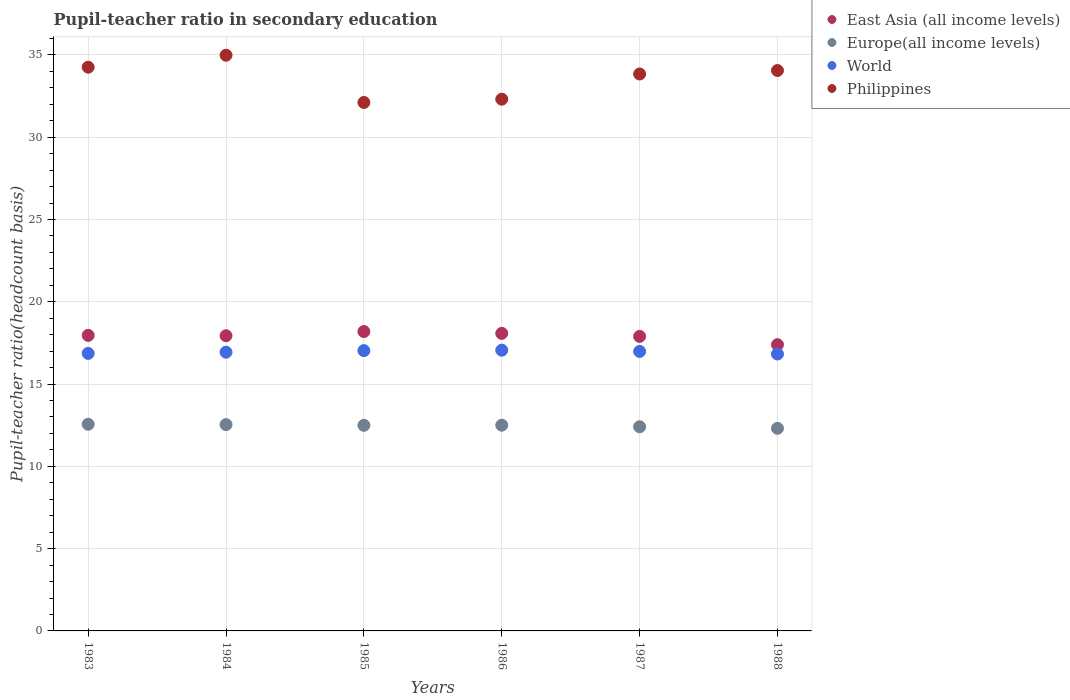What is the pupil-teacher ratio in secondary education in East Asia (all income levels) in 1983?
Your response must be concise. 17.96. Across all years, what is the maximum pupil-teacher ratio in secondary education in Philippines?
Offer a very short reply. 34.98. Across all years, what is the minimum pupil-teacher ratio in secondary education in World?
Provide a succinct answer. 16.83. In which year was the pupil-teacher ratio in secondary education in Philippines maximum?
Provide a short and direct response. 1984. What is the total pupil-teacher ratio in secondary education in Philippines in the graph?
Ensure brevity in your answer.  201.56. What is the difference between the pupil-teacher ratio in secondary education in World in 1985 and that in 1987?
Your response must be concise. 0.05. What is the difference between the pupil-teacher ratio in secondary education in Europe(all income levels) in 1986 and the pupil-teacher ratio in secondary education in East Asia (all income levels) in 1987?
Keep it short and to the point. -5.4. What is the average pupil-teacher ratio in secondary education in World per year?
Provide a short and direct response. 16.95. In the year 1983, what is the difference between the pupil-teacher ratio in secondary education in Philippines and pupil-teacher ratio in secondary education in World?
Provide a short and direct response. 17.39. In how many years, is the pupil-teacher ratio in secondary education in World greater than 11?
Your answer should be compact. 6. What is the ratio of the pupil-teacher ratio in secondary education in Europe(all income levels) in 1983 to that in 1985?
Keep it short and to the point. 1.01. What is the difference between the highest and the second highest pupil-teacher ratio in secondary education in East Asia (all income levels)?
Offer a terse response. 0.11. What is the difference between the highest and the lowest pupil-teacher ratio in secondary education in World?
Make the answer very short. 0.23. In how many years, is the pupil-teacher ratio in secondary education in World greater than the average pupil-teacher ratio in secondary education in World taken over all years?
Provide a short and direct response. 3. Is the sum of the pupil-teacher ratio in secondary education in Europe(all income levels) in 1984 and 1985 greater than the maximum pupil-teacher ratio in secondary education in Philippines across all years?
Provide a succinct answer. No. Is it the case that in every year, the sum of the pupil-teacher ratio in secondary education in East Asia (all income levels) and pupil-teacher ratio in secondary education in Europe(all income levels)  is greater than the sum of pupil-teacher ratio in secondary education in World and pupil-teacher ratio in secondary education in Philippines?
Offer a very short reply. No. Is it the case that in every year, the sum of the pupil-teacher ratio in secondary education in World and pupil-teacher ratio in secondary education in Europe(all income levels)  is greater than the pupil-teacher ratio in secondary education in Philippines?
Offer a terse response. No. Is the pupil-teacher ratio in secondary education in Philippines strictly less than the pupil-teacher ratio in secondary education in World over the years?
Provide a succinct answer. No. Does the graph contain any zero values?
Make the answer very short. No. Does the graph contain grids?
Provide a short and direct response. Yes. What is the title of the graph?
Offer a very short reply. Pupil-teacher ratio in secondary education. What is the label or title of the X-axis?
Provide a short and direct response. Years. What is the label or title of the Y-axis?
Keep it short and to the point. Pupil-teacher ratio(headcount basis). What is the Pupil-teacher ratio(headcount basis) of East Asia (all income levels) in 1983?
Offer a terse response. 17.96. What is the Pupil-teacher ratio(headcount basis) in Europe(all income levels) in 1983?
Make the answer very short. 12.56. What is the Pupil-teacher ratio(headcount basis) of World in 1983?
Provide a short and direct response. 16.86. What is the Pupil-teacher ratio(headcount basis) in Philippines in 1983?
Make the answer very short. 34.26. What is the Pupil-teacher ratio(headcount basis) in East Asia (all income levels) in 1984?
Keep it short and to the point. 17.94. What is the Pupil-teacher ratio(headcount basis) in Europe(all income levels) in 1984?
Give a very brief answer. 12.54. What is the Pupil-teacher ratio(headcount basis) in World in 1984?
Your answer should be compact. 16.94. What is the Pupil-teacher ratio(headcount basis) in Philippines in 1984?
Make the answer very short. 34.98. What is the Pupil-teacher ratio(headcount basis) of East Asia (all income levels) in 1985?
Keep it short and to the point. 18.19. What is the Pupil-teacher ratio(headcount basis) of Europe(all income levels) in 1985?
Ensure brevity in your answer.  12.49. What is the Pupil-teacher ratio(headcount basis) of World in 1985?
Make the answer very short. 17.03. What is the Pupil-teacher ratio(headcount basis) in Philippines in 1985?
Your answer should be compact. 32.11. What is the Pupil-teacher ratio(headcount basis) of East Asia (all income levels) in 1986?
Provide a succinct answer. 18.08. What is the Pupil-teacher ratio(headcount basis) in Europe(all income levels) in 1986?
Provide a short and direct response. 12.5. What is the Pupil-teacher ratio(headcount basis) of World in 1986?
Provide a succinct answer. 17.06. What is the Pupil-teacher ratio(headcount basis) in Philippines in 1986?
Your answer should be compact. 32.31. What is the Pupil-teacher ratio(headcount basis) of East Asia (all income levels) in 1987?
Your response must be concise. 17.9. What is the Pupil-teacher ratio(headcount basis) in Europe(all income levels) in 1987?
Your response must be concise. 12.41. What is the Pupil-teacher ratio(headcount basis) in World in 1987?
Make the answer very short. 16.98. What is the Pupil-teacher ratio(headcount basis) of Philippines in 1987?
Your answer should be very brief. 33.84. What is the Pupil-teacher ratio(headcount basis) in East Asia (all income levels) in 1988?
Provide a succinct answer. 17.4. What is the Pupil-teacher ratio(headcount basis) of Europe(all income levels) in 1988?
Offer a terse response. 12.31. What is the Pupil-teacher ratio(headcount basis) in World in 1988?
Offer a very short reply. 16.83. What is the Pupil-teacher ratio(headcount basis) of Philippines in 1988?
Your answer should be compact. 34.06. Across all years, what is the maximum Pupil-teacher ratio(headcount basis) of East Asia (all income levels)?
Offer a terse response. 18.19. Across all years, what is the maximum Pupil-teacher ratio(headcount basis) of Europe(all income levels)?
Provide a short and direct response. 12.56. Across all years, what is the maximum Pupil-teacher ratio(headcount basis) of World?
Keep it short and to the point. 17.06. Across all years, what is the maximum Pupil-teacher ratio(headcount basis) of Philippines?
Your response must be concise. 34.98. Across all years, what is the minimum Pupil-teacher ratio(headcount basis) in East Asia (all income levels)?
Your answer should be compact. 17.4. Across all years, what is the minimum Pupil-teacher ratio(headcount basis) in Europe(all income levels)?
Provide a short and direct response. 12.31. Across all years, what is the minimum Pupil-teacher ratio(headcount basis) of World?
Provide a succinct answer. 16.83. Across all years, what is the minimum Pupil-teacher ratio(headcount basis) of Philippines?
Give a very brief answer. 32.11. What is the total Pupil-teacher ratio(headcount basis) of East Asia (all income levels) in the graph?
Give a very brief answer. 107.47. What is the total Pupil-teacher ratio(headcount basis) in Europe(all income levels) in the graph?
Provide a succinct answer. 74.81. What is the total Pupil-teacher ratio(headcount basis) of World in the graph?
Ensure brevity in your answer.  101.7. What is the total Pupil-teacher ratio(headcount basis) of Philippines in the graph?
Give a very brief answer. 201.56. What is the difference between the Pupil-teacher ratio(headcount basis) of East Asia (all income levels) in 1983 and that in 1984?
Provide a succinct answer. 0.02. What is the difference between the Pupil-teacher ratio(headcount basis) of Europe(all income levels) in 1983 and that in 1984?
Keep it short and to the point. 0.02. What is the difference between the Pupil-teacher ratio(headcount basis) in World in 1983 and that in 1984?
Your answer should be compact. -0.07. What is the difference between the Pupil-teacher ratio(headcount basis) in Philippines in 1983 and that in 1984?
Your answer should be compact. -0.73. What is the difference between the Pupil-teacher ratio(headcount basis) in East Asia (all income levels) in 1983 and that in 1985?
Give a very brief answer. -0.23. What is the difference between the Pupil-teacher ratio(headcount basis) in Europe(all income levels) in 1983 and that in 1985?
Keep it short and to the point. 0.06. What is the difference between the Pupil-teacher ratio(headcount basis) in World in 1983 and that in 1985?
Your answer should be compact. -0.17. What is the difference between the Pupil-teacher ratio(headcount basis) in Philippines in 1983 and that in 1985?
Offer a terse response. 2.14. What is the difference between the Pupil-teacher ratio(headcount basis) in East Asia (all income levels) in 1983 and that in 1986?
Ensure brevity in your answer.  -0.12. What is the difference between the Pupil-teacher ratio(headcount basis) of Europe(all income levels) in 1983 and that in 1986?
Your answer should be very brief. 0.05. What is the difference between the Pupil-teacher ratio(headcount basis) of World in 1983 and that in 1986?
Your answer should be compact. -0.2. What is the difference between the Pupil-teacher ratio(headcount basis) in Philippines in 1983 and that in 1986?
Your answer should be compact. 1.94. What is the difference between the Pupil-teacher ratio(headcount basis) in East Asia (all income levels) in 1983 and that in 1987?
Provide a succinct answer. 0.06. What is the difference between the Pupil-teacher ratio(headcount basis) of Europe(all income levels) in 1983 and that in 1987?
Make the answer very short. 0.15. What is the difference between the Pupil-teacher ratio(headcount basis) of World in 1983 and that in 1987?
Offer a very short reply. -0.12. What is the difference between the Pupil-teacher ratio(headcount basis) in Philippines in 1983 and that in 1987?
Offer a very short reply. 0.41. What is the difference between the Pupil-teacher ratio(headcount basis) in East Asia (all income levels) in 1983 and that in 1988?
Your answer should be very brief. 0.56. What is the difference between the Pupil-teacher ratio(headcount basis) of Europe(all income levels) in 1983 and that in 1988?
Offer a very short reply. 0.25. What is the difference between the Pupil-teacher ratio(headcount basis) of World in 1983 and that in 1988?
Your answer should be very brief. 0.04. What is the difference between the Pupil-teacher ratio(headcount basis) of Philippines in 1983 and that in 1988?
Make the answer very short. 0.2. What is the difference between the Pupil-teacher ratio(headcount basis) of East Asia (all income levels) in 1984 and that in 1985?
Make the answer very short. -0.26. What is the difference between the Pupil-teacher ratio(headcount basis) in Europe(all income levels) in 1984 and that in 1985?
Provide a succinct answer. 0.04. What is the difference between the Pupil-teacher ratio(headcount basis) of World in 1984 and that in 1985?
Offer a terse response. -0.09. What is the difference between the Pupil-teacher ratio(headcount basis) of Philippines in 1984 and that in 1985?
Your answer should be compact. 2.87. What is the difference between the Pupil-teacher ratio(headcount basis) in East Asia (all income levels) in 1984 and that in 1986?
Provide a short and direct response. -0.14. What is the difference between the Pupil-teacher ratio(headcount basis) in Europe(all income levels) in 1984 and that in 1986?
Ensure brevity in your answer.  0.03. What is the difference between the Pupil-teacher ratio(headcount basis) in World in 1984 and that in 1986?
Your answer should be compact. -0.12. What is the difference between the Pupil-teacher ratio(headcount basis) of Philippines in 1984 and that in 1986?
Provide a short and direct response. 2.67. What is the difference between the Pupil-teacher ratio(headcount basis) of East Asia (all income levels) in 1984 and that in 1987?
Give a very brief answer. 0.04. What is the difference between the Pupil-teacher ratio(headcount basis) of Europe(all income levels) in 1984 and that in 1987?
Make the answer very short. 0.13. What is the difference between the Pupil-teacher ratio(headcount basis) in World in 1984 and that in 1987?
Offer a terse response. -0.05. What is the difference between the Pupil-teacher ratio(headcount basis) in Philippines in 1984 and that in 1987?
Make the answer very short. 1.14. What is the difference between the Pupil-teacher ratio(headcount basis) in East Asia (all income levels) in 1984 and that in 1988?
Offer a very short reply. 0.54. What is the difference between the Pupil-teacher ratio(headcount basis) in Europe(all income levels) in 1984 and that in 1988?
Ensure brevity in your answer.  0.23. What is the difference between the Pupil-teacher ratio(headcount basis) of World in 1984 and that in 1988?
Ensure brevity in your answer.  0.11. What is the difference between the Pupil-teacher ratio(headcount basis) of Philippines in 1984 and that in 1988?
Your answer should be very brief. 0.93. What is the difference between the Pupil-teacher ratio(headcount basis) in East Asia (all income levels) in 1985 and that in 1986?
Give a very brief answer. 0.11. What is the difference between the Pupil-teacher ratio(headcount basis) of Europe(all income levels) in 1985 and that in 1986?
Your answer should be very brief. -0.01. What is the difference between the Pupil-teacher ratio(headcount basis) of World in 1985 and that in 1986?
Give a very brief answer. -0.03. What is the difference between the Pupil-teacher ratio(headcount basis) in Philippines in 1985 and that in 1986?
Make the answer very short. -0.2. What is the difference between the Pupil-teacher ratio(headcount basis) of East Asia (all income levels) in 1985 and that in 1987?
Give a very brief answer. 0.29. What is the difference between the Pupil-teacher ratio(headcount basis) of Europe(all income levels) in 1985 and that in 1987?
Make the answer very short. 0.09. What is the difference between the Pupil-teacher ratio(headcount basis) of World in 1985 and that in 1987?
Your answer should be compact. 0.05. What is the difference between the Pupil-teacher ratio(headcount basis) of Philippines in 1985 and that in 1987?
Your answer should be compact. -1.73. What is the difference between the Pupil-teacher ratio(headcount basis) of East Asia (all income levels) in 1985 and that in 1988?
Provide a succinct answer. 0.8. What is the difference between the Pupil-teacher ratio(headcount basis) of Europe(all income levels) in 1985 and that in 1988?
Ensure brevity in your answer.  0.18. What is the difference between the Pupil-teacher ratio(headcount basis) in World in 1985 and that in 1988?
Provide a succinct answer. 0.21. What is the difference between the Pupil-teacher ratio(headcount basis) of Philippines in 1985 and that in 1988?
Offer a terse response. -1.94. What is the difference between the Pupil-teacher ratio(headcount basis) in East Asia (all income levels) in 1986 and that in 1987?
Provide a succinct answer. 0.18. What is the difference between the Pupil-teacher ratio(headcount basis) of Europe(all income levels) in 1986 and that in 1987?
Make the answer very short. 0.1. What is the difference between the Pupil-teacher ratio(headcount basis) of World in 1986 and that in 1987?
Ensure brevity in your answer.  0.08. What is the difference between the Pupil-teacher ratio(headcount basis) in Philippines in 1986 and that in 1987?
Provide a short and direct response. -1.53. What is the difference between the Pupil-teacher ratio(headcount basis) in East Asia (all income levels) in 1986 and that in 1988?
Your answer should be compact. 0.69. What is the difference between the Pupil-teacher ratio(headcount basis) of Europe(all income levels) in 1986 and that in 1988?
Make the answer very short. 0.19. What is the difference between the Pupil-teacher ratio(headcount basis) of World in 1986 and that in 1988?
Provide a succinct answer. 0.23. What is the difference between the Pupil-teacher ratio(headcount basis) in Philippines in 1986 and that in 1988?
Offer a very short reply. -1.74. What is the difference between the Pupil-teacher ratio(headcount basis) of East Asia (all income levels) in 1987 and that in 1988?
Keep it short and to the point. 0.5. What is the difference between the Pupil-teacher ratio(headcount basis) of Europe(all income levels) in 1987 and that in 1988?
Make the answer very short. 0.09. What is the difference between the Pupil-teacher ratio(headcount basis) in World in 1987 and that in 1988?
Give a very brief answer. 0.16. What is the difference between the Pupil-teacher ratio(headcount basis) in Philippines in 1987 and that in 1988?
Your answer should be very brief. -0.21. What is the difference between the Pupil-teacher ratio(headcount basis) in East Asia (all income levels) in 1983 and the Pupil-teacher ratio(headcount basis) in Europe(all income levels) in 1984?
Give a very brief answer. 5.42. What is the difference between the Pupil-teacher ratio(headcount basis) of East Asia (all income levels) in 1983 and the Pupil-teacher ratio(headcount basis) of World in 1984?
Your answer should be compact. 1.02. What is the difference between the Pupil-teacher ratio(headcount basis) of East Asia (all income levels) in 1983 and the Pupil-teacher ratio(headcount basis) of Philippines in 1984?
Make the answer very short. -17.02. What is the difference between the Pupil-teacher ratio(headcount basis) in Europe(all income levels) in 1983 and the Pupil-teacher ratio(headcount basis) in World in 1984?
Offer a terse response. -4.38. What is the difference between the Pupil-teacher ratio(headcount basis) of Europe(all income levels) in 1983 and the Pupil-teacher ratio(headcount basis) of Philippines in 1984?
Ensure brevity in your answer.  -22.43. What is the difference between the Pupil-teacher ratio(headcount basis) in World in 1983 and the Pupil-teacher ratio(headcount basis) in Philippines in 1984?
Make the answer very short. -18.12. What is the difference between the Pupil-teacher ratio(headcount basis) in East Asia (all income levels) in 1983 and the Pupil-teacher ratio(headcount basis) in Europe(all income levels) in 1985?
Give a very brief answer. 5.47. What is the difference between the Pupil-teacher ratio(headcount basis) in East Asia (all income levels) in 1983 and the Pupil-teacher ratio(headcount basis) in World in 1985?
Your response must be concise. 0.93. What is the difference between the Pupil-teacher ratio(headcount basis) in East Asia (all income levels) in 1983 and the Pupil-teacher ratio(headcount basis) in Philippines in 1985?
Offer a very short reply. -14.15. What is the difference between the Pupil-teacher ratio(headcount basis) in Europe(all income levels) in 1983 and the Pupil-teacher ratio(headcount basis) in World in 1985?
Make the answer very short. -4.48. What is the difference between the Pupil-teacher ratio(headcount basis) of Europe(all income levels) in 1983 and the Pupil-teacher ratio(headcount basis) of Philippines in 1985?
Ensure brevity in your answer.  -19.56. What is the difference between the Pupil-teacher ratio(headcount basis) of World in 1983 and the Pupil-teacher ratio(headcount basis) of Philippines in 1985?
Offer a very short reply. -15.25. What is the difference between the Pupil-teacher ratio(headcount basis) in East Asia (all income levels) in 1983 and the Pupil-teacher ratio(headcount basis) in Europe(all income levels) in 1986?
Offer a very short reply. 5.46. What is the difference between the Pupil-teacher ratio(headcount basis) of East Asia (all income levels) in 1983 and the Pupil-teacher ratio(headcount basis) of World in 1986?
Provide a short and direct response. 0.9. What is the difference between the Pupil-teacher ratio(headcount basis) in East Asia (all income levels) in 1983 and the Pupil-teacher ratio(headcount basis) in Philippines in 1986?
Offer a very short reply. -14.35. What is the difference between the Pupil-teacher ratio(headcount basis) in Europe(all income levels) in 1983 and the Pupil-teacher ratio(headcount basis) in World in 1986?
Provide a succinct answer. -4.5. What is the difference between the Pupil-teacher ratio(headcount basis) of Europe(all income levels) in 1983 and the Pupil-teacher ratio(headcount basis) of Philippines in 1986?
Your answer should be very brief. -19.76. What is the difference between the Pupil-teacher ratio(headcount basis) in World in 1983 and the Pupil-teacher ratio(headcount basis) in Philippines in 1986?
Offer a very short reply. -15.45. What is the difference between the Pupil-teacher ratio(headcount basis) of East Asia (all income levels) in 1983 and the Pupil-teacher ratio(headcount basis) of Europe(all income levels) in 1987?
Provide a short and direct response. 5.55. What is the difference between the Pupil-teacher ratio(headcount basis) of East Asia (all income levels) in 1983 and the Pupil-teacher ratio(headcount basis) of World in 1987?
Your response must be concise. 0.98. What is the difference between the Pupil-teacher ratio(headcount basis) in East Asia (all income levels) in 1983 and the Pupil-teacher ratio(headcount basis) in Philippines in 1987?
Make the answer very short. -15.88. What is the difference between the Pupil-teacher ratio(headcount basis) of Europe(all income levels) in 1983 and the Pupil-teacher ratio(headcount basis) of World in 1987?
Offer a very short reply. -4.43. What is the difference between the Pupil-teacher ratio(headcount basis) in Europe(all income levels) in 1983 and the Pupil-teacher ratio(headcount basis) in Philippines in 1987?
Give a very brief answer. -21.29. What is the difference between the Pupil-teacher ratio(headcount basis) in World in 1983 and the Pupil-teacher ratio(headcount basis) in Philippines in 1987?
Keep it short and to the point. -16.98. What is the difference between the Pupil-teacher ratio(headcount basis) in East Asia (all income levels) in 1983 and the Pupil-teacher ratio(headcount basis) in Europe(all income levels) in 1988?
Your response must be concise. 5.65. What is the difference between the Pupil-teacher ratio(headcount basis) in East Asia (all income levels) in 1983 and the Pupil-teacher ratio(headcount basis) in World in 1988?
Provide a short and direct response. 1.13. What is the difference between the Pupil-teacher ratio(headcount basis) of East Asia (all income levels) in 1983 and the Pupil-teacher ratio(headcount basis) of Philippines in 1988?
Keep it short and to the point. -16.1. What is the difference between the Pupil-teacher ratio(headcount basis) of Europe(all income levels) in 1983 and the Pupil-teacher ratio(headcount basis) of World in 1988?
Provide a succinct answer. -4.27. What is the difference between the Pupil-teacher ratio(headcount basis) of Europe(all income levels) in 1983 and the Pupil-teacher ratio(headcount basis) of Philippines in 1988?
Give a very brief answer. -21.5. What is the difference between the Pupil-teacher ratio(headcount basis) in World in 1983 and the Pupil-teacher ratio(headcount basis) in Philippines in 1988?
Your response must be concise. -17.19. What is the difference between the Pupil-teacher ratio(headcount basis) of East Asia (all income levels) in 1984 and the Pupil-teacher ratio(headcount basis) of Europe(all income levels) in 1985?
Your answer should be compact. 5.44. What is the difference between the Pupil-teacher ratio(headcount basis) of East Asia (all income levels) in 1984 and the Pupil-teacher ratio(headcount basis) of World in 1985?
Keep it short and to the point. 0.91. What is the difference between the Pupil-teacher ratio(headcount basis) of East Asia (all income levels) in 1984 and the Pupil-teacher ratio(headcount basis) of Philippines in 1985?
Offer a terse response. -14.18. What is the difference between the Pupil-teacher ratio(headcount basis) of Europe(all income levels) in 1984 and the Pupil-teacher ratio(headcount basis) of World in 1985?
Make the answer very short. -4.5. What is the difference between the Pupil-teacher ratio(headcount basis) of Europe(all income levels) in 1984 and the Pupil-teacher ratio(headcount basis) of Philippines in 1985?
Offer a terse response. -19.58. What is the difference between the Pupil-teacher ratio(headcount basis) in World in 1984 and the Pupil-teacher ratio(headcount basis) in Philippines in 1985?
Give a very brief answer. -15.18. What is the difference between the Pupil-teacher ratio(headcount basis) of East Asia (all income levels) in 1984 and the Pupil-teacher ratio(headcount basis) of Europe(all income levels) in 1986?
Offer a terse response. 5.43. What is the difference between the Pupil-teacher ratio(headcount basis) in East Asia (all income levels) in 1984 and the Pupil-teacher ratio(headcount basis) in World in 1986?
Your answer should be very brief. 0.88. What is the difference between the Pupil-teacher ratio(headcount basis) in East Asia (all income levels) in 1984 and the Pupil-teacher ratio(headcount basis) in Philippines in 1986?
Keep it short and to the point. -14.38. What is the difference between the Pupil-teacher ratio(headcount basis) of Europe(all income levels) in 1984 and the Pupil-teacher ratio(headcount basis) of World in 1986?
Ensure brevity in your answer.  -4.52. What is the difference between the Pupil-teacher ratio(headcount basis) in Europe(all income levels) in 1984 and the Pupil-teacher ratio(headcount basis) in Philippines in 1986?
Provide a short and direct response. -19.78. What is the difference between the Pupil-teacher ratio(headcount basis) of World in 1984 and the Pupil-teacher ratio(headcount basis) of Philippines in 1986?
Offer a very short reply. -15.38. What is the difference between the Pupil-teacher ratio(headcount basis) of East Asia (all income levels) in 1984 and the Pupil-teacher ratio(headcount basis) of Europe(all income levels) in 1987?
Your answer should be very brief. 5.53. What is the difference between the Pupil-teacher ratio(headcount basis) of East Asia (all income levels) in 1984 and the Pupil-teacher ratio(headcount basis) of World in 1987?
Ensure brevity in your answer.  0.95. What is the difference between the Pupil-teacher ratio(headcount basis) of East Asia (all income levels) in 1984 and the Pupil-teacher ratio(headcount basis) of Philippines in 1987?
Your answer should be very brief. -15.91. What is the difference between the Pupil-teacher ratio(headcount basis) in Europe(all income levels) in 1984 and the Pupil-teacher ratio(headcount basis) in World in 1987?
Provide a succinct answer. -4.45. What is the difference between the Pupil-teacher ratio(headcount basis) in Europe(all income levels) in 1984 and the Pupil-teacher ratio(headcount basis) in Philippines in 1987?
Ensure brevity in your answer.  -21.31. What is the difference between the Pupil-teacher ratio(headcount basis) of World in 1984 and the Pupil-teacher ratio(headcount basis) of Philippines in 1987?
Keep it short and to the point. -16.91. What is the difference between the Pupil-teacher ratio(headcount basis) of East Asia (all income levels) in 1984 and the Pupil-teacher ratio(headcount basis) of Europe(all income levels) in 1988?
Provide a short and direct response. 5.63. What is the difference between the Pupil-teacher ratio(headcount basis) in East Asia (all income levels) in 1984 and the Pupil-teacher ratio(headcount basis) in World in 1988?
Provide a short and direct response. 1.11. What is the difference between the Pupil-teacher ratio(headcount basis) in East Asia (all income levels) in 1984 and the Pupil-teacher ratio(headcount basis) in Philippines in 1988?
Offer a terse response. -16.12. What is the difference between the Pupil-teacher ratio(headcount basis) of Europe(all income levels) in 1984 and the Pupil-teacher ratio(headcount basis) of World in 1988?
Make the answer very short. -4.29. What is the difference between the Pupil-teacher ratio(headcount basis) of Europe(all income levels) in 1984 and the Pupil-teacher ratio(headcount basis) of Philippines in 1988?
Your answer should be compact. -21.52. What is the difference between the Pupil-teacher ratio(headcount basis) in World in 1984 and the Pupil-teacher ratio(headcount basis) in Philippines in 1988?
Your answer should be very brief. -17.12. What is the difference between the Pupil-teacher ratio(headcount basis) of East Asia (all income levels) in 1985 and the Pupil-teacher ratio(headcount basis) of Europe(all income levels) in 1986?
Provide a succinct answer. 5.69. What is the difference between the Pupil-teacher ratio(headcount basis) of East Asia (all income levels) in 1985 and the Pupil-teacher ratio(headcount basis) of World in 1986?
Offer a very short reply. 1.13. What is the difference between the Pupil-teacher ratio(headcount basis) in East Asia (all income levels) in 1985 and the Pupil-teacher ratio(headcount basis) in Philippines in 1986?
Offer a terse response. -14.12. What is the difference between the Pupil-teacher ratio(headcount basis) in Europe(all income levels) in 1985 and the Pupil-teacher ratio(headcount basis) in World in 1986?
Provide a short and direct response. -4.57. What is the difference between the Pupil-teacher ratio(headcount basis) of Europe(all income levels) in 1985 and the Pupil-teacher ratio(headcount basis) of Philippines in 1986?
Your answer should be compact. -19.82. What is the difference between the Pupil-teacher ratio(headcount basis) in World in 1985 and the Pupil-teacher ratio(headcount basis) in Philippines in 1986?
Ensure brevity in your answer.  -15.28. What is the difference between the Pupil-teacher ratio(headcount basis) of East Asia (all income levels) in 1985 and the Pupil-teacher ratio(headcount basis) of Europe(all income levels) in 1987?
Your answer should be very brief. 5.79. What is the difference between the Pupil-teacher ratio(headcount basis) in East Asia (all income levels) in 1985 and the Pupil-teacher ratio(headcount basis) in World in 1987?
Give a very brief answer. 1.21. What is the difference between the Pupil-teacher ratio(headcount basis) in East Asia (all income levels) in 1985 and the Pupil-teacher ratio(headcount basis) in Philippines in 1987?
Your response must be concise. -15.65. What is the difference between the Pupil-teacher ratio(headcount basis) in Europe(all income levels) in 1985 and the Pupil-teacher ratio(headcount basis) in World in 1987?
Ensure brevity in your answer.  -4.49. What is the difference between the Pupil-teacher ratio(headcount basis) in Europe(all income levels) in 1985 and the Pupil-teacher ratio(headcount basis) in Philippines in 1987?
Your answer should be compact. -21.35. What is the difference between the Pupil-teacher ratio(headcount basis) in World in 1985 and the Pupil-teacher ratio(headcount basis) in Philippines in 1987?
Your answer should be very brief. -16.81. What is the difference between the Pupil-teacher ratio(headcount basis) of East Asia (all income levels) in 1985 and the Pupil-teacher ratio(headcount basis) of Europe(all income levels) in 1988?
Ensure brevity in your answer.  5.88. What is the difference between the Pupil-teacher ratio(headcount basis) in East Asia (all income levels) in 1985 and the Pupil-teacher ratio(headcount basis) in World in 1988?
Your response must be concise. 1.37. What is the difference between the Pupil-teacher ratio(headcount basis) in East Asia (all income levels) in 1985 and the Pupil-teacher ratio(headcount basis) in Philippines in 1988?
Your response must be concise. -15.86. What is the difference between the Pupil-teacher ratio(headcount basis) in Europe(all income levels) in 1985 and the Pupil-teacher ratio(headcount basis) in World in 1988?
Your answer should be very brief. -4.33. What is the difference between the Pupil-teacher ratio(headcount basis) in Europe(all income levels) in 1985 and the Pupil-teacher ratio(headcount basis) in Philippines in 1988?
Ensure brevity in your answer.  -21.56. What is the difference between the Pupil-teacher ratio(headcount basis) in World in 1985 and the Pupil-teacher ratio(headcount basis) in Philippines in 1988?
Your response must be concise. -17.02. What is the difference between the Pupil-teacher ratio(headcount basis) in East Asia (all income levels) in 1986 and the Pupil-teacher ratio(headcount basis) in Europe(all income levels) in 1987?
Make the answer very short. 5.67. What is the difference between the Pupil-teacher ratio(headcount basis) in East Asia (all income levels) in 1986 and the Pupil-teacher ratio(headcount basis) in World in 1987?
Provide a succinct answer. 1.1. What is the difference between the Pupil-teacher ratio(headcount basis) of East Asia (all income levels) in 1986 and the Pupil-teacher ratio(headcount basis) of Philippines in 1987?
Keep it short and to the point. -15.76. What is the difference between the Pupil-teacher ratio(headcount basis) of Europe(all income levels) in 1986 and the Pupil-teacher ratio(headcount basis) of World in 1987?
Keep it short and to the point. -4.48. What is the difference between the Pupil-teacher ratio(headcount basis) of Europe(all income levels) in 1986 and the Pupil-teacher ratio(headcount basis) of Philippines in 1987?
Offer a very short reply. -21.34. What is the difference between the Pupil-teacher ratio(headcount basis) in World in 1986 and the Pupil-teacher ratio(headcount basis) in Philippines in 1987?
Provide a short and direct response. -16.78. What is the difference between the Pupil-teacher ratio(headcount basis) in East Asia (all income levels) in 1986 and the Pupil-teacher ratio(headcount basis) in Europe(all income levels) in 1988?
Offer a terse response. 5.77. What is the difference between the Pupil-teacher ratio(headcount basis) in East Asia (all income levels) in 1986 and the Pupil-teacher ratio(headcount basis) in World in 1988?
Ensure brevity in your answer.  1.25. What is the difference between the Pupil-teacher ratio(headcount basis) of East Asia (all income levels) in 1986 and the Pupil-teacher ratio(headcount basis) of Philippines in 1988?
Offer a terse response. -15.97. What is the difference between the Pupil-teacher ratio(headcount basis) of Europe(all income levels) in 1986 and the Pupil-teacher ratio(headcount basis) of World in 1988?
Keep it short and to the point. -4.32. What is the difference between the Pupil-teacher ratio(headcount basis) in Europe(all income levels) in 1986 and the Pupil-teacher ratio(headcount basis) in Philippines in 1988?
Make the answer very short. -21.55. What is the difference between the Pupil-teacher ratio(headcount basis) in World in 1986 and the Pupil-teacher ratio(headcount basis) in Philippines in 1988?
Give a very brief answer. -17. What is the difference between the Pupil-teacher ratio(headcount basis) of East Asia (all income levels) in 1987 and the Pupil-teacher ratio(headcount basis) of Europe(all income levels) in 1988?
Provide a succinct answer. 5.59. What is the difference between the Pupil-teacher ratio(headcount basis) in East Asia (all income levels) in 1987 and the Pupil-teacher ratio(headcount basis) in World in 1988?
Your answer should be very brief. 1.07. What is the difference between the Pupil-teacher ratio(headcount basis) in East Asia (all income levels) in 1987 and the Pupil-teacher ratio(headcount basis) in Philippines in 1988?
Offer a terse response. -16.16. What is the difference between the Pupil-teacher ratio(headcount basis) of Europe(all income levels) in 1987 and the Pupil-teacher ratio(headcount basis) of World in 1988?
Your answer should be very brief. -4.42. What is the difference between the Pupil-teacher ratio(headcount basis) in Europe(all income levels) in 1987 and the Pupil-teacher ratio(headcount basis) in Philippines in 1988?
Keep it short and to the point. -21.65. What is the difference between the Pupil-teacher ratio(headcount basis) in World in 1987 and the Pupil-teacher ratio(headcount basis) in Philippines in 1988?
Provide a succinct answer. -17.07. What is the average Pupil-teacher ratio(headcount basis) of East Asia (all income levels) per year?
Provide a succinct answer. 17.91. What is the average Pupil-teacher ratio(headcount basis) in Europe(all income levels) per year?
Provide a short and direct response. 12.47. What is the average Pupil-teacher ratio(headcount basis) of World per year?
Your response must be concise. 16.95. What is the average Pupil-teacher ratio(headcount basis) of Philippines per year?
Give a very brief answer. 33.59. In the year 1983, what is the difference between the Pupil-teacher ratio(headcount basis) in East Asia (all income levels) and Pupil-teacher ratio(headcount basis) in Europe(all income levels)?
Ensure brevity in your answer.  5.4. In the year 1983, what is the difference between the Pupil-teacher ratio(headcount basis) of East Asia (all income levels) and Pupil-teacher ratio(headcount basis) of World?
Ensure brevity in your answer.  1.1. In the year 1983, what is the difference between the Pupil-teacher ratio(headcount basis) of East Asia (all income levels) and Pupil-teacher ratio(headcount basis) of Philippines?
Make the answer very short. -16.3. In the year 1983, what is the difference between the Pupil-teacher ratio(headcount basis) in Europe(all income levels) and Pupil-teacher ratio(headcount basis) in World?
Keep it short and to the point. -4.31. In the year 1983, what is the difference between the Pupil-teacher ratio(headcount basis) in Europe(all income levels) and Pupil-teacher ratio(headcount basis) in Philippines?
Your response must be concise. -21.7. In the year 1983, what is the difference between the Pupil-teacher ratio(headcount basis) in World and Pupil-teacher ratio(headcount basis) in Philippines?
Give a very brief answer. -17.39. In the year 1984, what is the difference between the Pupil-teacher ratio(headcount basis) in East Asia (all income levels) and Pupil-teacher ratio(headcount basis) in Europe(all income levels)?
Offer a very short reply. 5.4. In the year 1984, what is the difference between the Pupil-teacher ratio(headcount basis) in East Asia (all income levels) and Pupil-teacher ratio(headcount basis) in Philippines?
Provide a short and direct response. -17.05. In the year 1984, what is the difference between the Pupil-teacher ratio(headcount basis) in Europe(all income levels) and Pupil-teacher ratio(headcount basis) in World?
Give a very brief answer. -4.4. In the year 1984, what is the difference between the Pupil-teacher ratio(headcount basis) in Europe(all income levels) and Pupil-teacher ratio(headcount basis) in Philippines?
Offer a terse response. -22.45. In the year 1984, what is the difference between the Pupil-teacher ratio(headcount basis) in World and Pupil-teacher ratio(headcount basis) in Philippines?
Your response must be concise. -18.05. In the year 1985, what is the difference between the Pupil-teacher ratio(headcount basis) in East Asia (all income levels) and Pupil-teacher ratio(headcount basis) in Europe(all income levels)?
Your answer should be very brief. 5.7. In the year 1985, what is the difference between the Pupil-teacher ratio(headcount basis) in East Asia (all income levels) and Pupil-teacher ratio(headcount basis) in World?
Keep it short and to the point. 1.16. In the year 1985, what is the difference between the Pupil-teacher ratio(headcount basis) of East Asia (all income levels) and Pupil-teacher ratio(headcount basis) of Philippines?
Offer a very short reply. -13.92. In the year 1985, what is the difference between the Pupil-teacher ratio(headcount basis) of Europe(all income levels) and Pupil-teacher ratio(headcount basis) of World?
Provide a short and direct response. -4.54. In the year 1985, what is the difference between the Pupil-teacher ratio(headcount basis) in Europe(all income levels) and Pupil-teacher ratio(headcount basis) in Philippines?
Provide a short and direct response. -19.62. In the year 1985, what is the difference between the Pupil-teacher ratio(headcount basis) in World and Pupil-teacher ratio(headcount basis) in Philippines?
Your response must be concise. -15.08. In the year 1986, what is the difference between the Pupil-teacher ratio(headcount basis) of East Asia (all income levels) and Pupil-teacher ratio(headcount basis) of Europe(all income levels)?
Provide a short and direct response. 5.58. In the year 1986, what is the difference between the Pupil-teacher ratio(headcount basis) in East Asia (all income levels) and Pupil-teacher ratio(headcount basis) in World?
Ensure brevity in your answer.  1.02. In the year 1986, what is the difference between the Pupil-teacher ratio(headcount basis) of East Asia (all income levels) and Pupil-teacher ratio(headcount basis) of Philippines?
Your answer should be compact. -14.23. In the year 1986, what is the difference between the Pupil-teacher ratio(headcount basis) of Europe(all income levels) and Pupil-teacher ratio(headcount basis) of World?
Provide a succinct answer. -4.56. In the year 1986, what is the difference between the Pupil-teacher ratio(headcount basis) of Europe(all income levels) and Pupil-teacher ratio(headcount basis) of Philippines?
Offer a very short reply. -19.81. In the year 1986, what is the difference between the Pupil-teacher ratio(headcount basis) in World and Pupil-teacher ratio(headcount basis) in Philippines?
Give a very brief answer. -15.25. In the year 1987, what is the difference between the Pupil-teacher ratio(headcount basis) in East Asia (all income levels) and Pupil-teacher ratio(headcount basis) in Europe(all income levels)?
Your answer should be very brief. 5.49. In the year 1987, what is the difference between the Pupil-teacher ratio(headcount basis) of East Asia (all income levels) and Pupil-teacher ratio(headcount basis) of World?
Your answer should be compact. 0.91. In the year 1987, what is the difference between the Pupil-teacher ratio(headcount basis) in East Asia (all income levels) and Pupil-teacher ratio(headcount basis) in Philippines?
Provide a short and direct response. -15.94. In the year 1987, what is the difference between the Pupil-teacher ratio(headcount basis) in Europe(all income levels) and Pupil-teacher ratio(headcount basis) in World?
Offer a very short reply. -4.58. In the year 1987, what is the difference between the Pupil-teacher ratio(headcount basis) in Europe(all income levels) and Pupil-teacher ratio(headcount basis) in Philippines?
Provide a short and direct response. -21.44. In the year 1987, what is the difference between the Pupil-teacher ratio(headcount basis) of World and Pupil-teacher ratio(headcount basis) of Philippines?
Keep it short and to the point. -16.86. In the year 1988, what is the difference between the Pupil-teacher ratio(headcount basis) in East Asia (all income levels) and Pupil-teacher ratio(headcount basis) in Europe(all income levels)?
Give a very brief answer. 5.08. In the year 1988, what is the difference between the Pupil-teacher ratio(headcount basis) in East Asia (all income levels) and Pupil-teacher ratio(headcount basis) in World?
Your answer should be compact. 0.57. In the year 1988, what is the difference between the Pupil-teacher ratio(headcount basis) in East Asia (all income levels) and Pupil-teacher ratio(headcount basis) in Philippines?
Your answer should be compact. -16.66. In the year 1988, what is the difference between the Pupil-teacher ratio(headcount basis) of Europe(all income levels) and Pupil-teacher ratio(headcount basis) of World?
Provide a short and direct response. -4.52. In the year 1988, what is the difference between the Pupil-teacher ratio(headcount basis) in Europe(all income levels) and Pupil-teacher ratio(headcount basis) in Philippines?
Provide a succinct answer. -21.74. In the year 1988, what is the difference between the Pupil-teacher ratio(headcount basis) of World and Pupil-teacher ratio(headcount basis) of Philippines?
Your answer should be compact. -17.23. What is the ratio of the Pupil-teacher ratio(headcount basis) in World in 1983 to that in 1984?
Your answer should be very brief. 1. What is the ratio of the Pupil-teacher ratio(headcount basis) in Philippines in 1983 to that in 1984?
Ensure brevity in your answer.  0.98. What is the ratio of the Pupil-teacher ratio(headcount basis) of East Asia (all income levels) in 1983 to that in 1985?
Give a very brief answer. 0.99. What is the ratio of the Pupil-teacher ratio(headcount basis) in Philippines in 1983 to that in 1985?
Keep it short and to the point. 1.07. What is the ratio of the Pupil-teacher ratio(headcount basis) of Europe(all income levels) in 1983 to that in 1986?
Your response must be concise. 1. What is the ratio of the Pupil-teacher ratio(headcount basis) in Philippines in 1983 to that in 1986?
Ensure brevity in your answer.  1.06. What is the ratio of the Pupil-teacher ratio(headcount basis) of East Asia (all income levels) in 1983 to that in 1987?
Offer a very short reply. 1. What is the ratio of the Pupil-teacher ratio(headcount basis) in Europe(all income levels) in 1983 to that in 1987?
Your response must be concise. 1.01. What is the ratio of the Pupil-teacher ratio(headcount basis) in Philippines in 1983 to that in 1987?
Your answer should be compact. 1.01. What is the ratio of the Pupil-teacher ratio(headcount basis) of East Asia (all income levels) in 1983 to that in 1988?
Keep it short and to the point. 1.03. What is the ratio of the Pupil-teacher ratio(headcount basis) of World in 1983 to that in 1988?
Offer a terse response. 1. What is the ratio of the Pupil-teacher ratio(headcount basis) in Philippines in 1983 to that in 1988?
Ensure brevity in your answer.  1.01. What is the ratio of the Pupil-teacher ratio(headcount basis) in East Asia (all income levels) in 1984 to that in 1985?
Make the answer very short. 0.99. What is the ratio of the Pupil-teacher ratio(headcount basis) of Europe(all income levels) in 1984 to that in 1985?
Provide a succinct answer. 1. What is the ratio of the Pupil-teacher ratio(headcount basis) in World in 1984 to that in 1985?
Provide a short and direct response. 0.99. What is the ratio of the Pupil-teacher ratio(headcount basis) in Philippines in 1984 to that in 1985?
Offer a terse response. 1.09. What is the ratio of the Pupil-teacher ratio(headcount basis) in East Asia (all income levels) in 1984 to that in 1986?
Make the answer very short. 0.99. What is the ratio of the Pupil-teacher ratio(headcount basis) of Europe(all income levels) in 1984 to that in 1986?
Your answer should be very brief. 1. What is the ratio of the Pupil-teacher ratio(headcount basis) of World in 1984 to that in 1986?
Give a very brief answer. 0.99. What is the ratio of the Pupil-teacher ratio(headcount basis) in Philippines in 1984 to that in 1986?
Offer a terse response. 1.08. What is the ratio of the Pupil-teacher ratio(headcount basis) of Europe(all income levels) in 1984 to that in 1987?
Ensure brevity in your answer.  1.01. What is the ratio of the Pupil-teacher ratio(headcount basis) in Philippines in 1984 to that in 1987?
Give a very brief answer. 1.03. What is the ratio of the Pupil-teacher ratio(headcount basis) in East Asia (all income levels) in 1984 to that in 1988?
Give a very brief answer. 1.03. What is the ratio of the Pupil-teacher ratio(headcount basis) of Europe(all income levels) in 1984 to that in 1988?
Provide a succinct answer. 1.02. What is the ratio of the Pupil-teacher ratio(headcount basis) in World in 1984 to that in 1988?
Provide a succinct answer. 1.01. What is the ratio of the Pupil-teacher ratio(headcount basis) of Philippines in 1984 to that in 1988?
Offer a terse response. 1.03. What is the ratio of the Pupil-teacher ratio(headcount basis) of East Asia (all income levels) in 1985 to that in 1986?
Offer a terse response. 1.01. What is the ratio of the Pupil-teacher ratio(headcount basis) of East Asia (all income levels) in 1985 to that in 1987?
Your response must be concise. 1.02. What is the ratio of the Pupil-teacher ratio(headcount basis) in Europe(all income levels) in 1985 to that in 1987?
Ensure brevity in your answer.  1.01. What is the ratio of the Pupil-teacher ratio(headcount basis) of World in 1985 to that in 1987?
Offer a terse response. 1. What is the ratio of the Pupil-teacher ratio(headcount basis) in Philippines in 1985 to that in 1987?
Offer a terse response. 0.95. What is the ratio of the Pupil-teacher ratio(headcount basis) in East Asia (all income levels) in 1985 to that in 1988?
Give a very brief answer. 1.05. What is the ratio of the Pupil-teacher ratio(headcount basis) in Europe(all income levels) in 1985 to that in 1988?
Your answer should be compact. 1.01. What is the ratio of the Pupil-teacher ratio(headcount basis) of World in 1985 to that in 1988?
Your answer should be very brief. 1.01. What is the ratio of the Pupil-teacher ratio(headcount basis) of Philippines in 1985 to that in 1988?
Your answer should be compact. 0.94. What is the ratio of the Pupil-teacher ratio(headcount basis) of East Asia (all income levels) in 1986 to that in 1987?
Provide a short and direct response. 1.01. What is the ratio of the Pupil-teacher ratio(headcount basis) of Europe(all income levels) in 1986 to that in 1987?
Keep it short and to the point. 1.01. What is the ratio of the Pupil-teacher ratio(headcount basis) of Philippines in 1986 to that in 1987?
Ensure brevity in your answer.  0.95. What is the ratio of the Pupil-teacher ratio(headcount basis) of East Asia (all income levels) in 1986 to that in 1988?
Your response must be concise. 1.04. What is the ratio of the Pupil-teacher ratio(headcount basis) of Europe(all income levels) in 1986 to that in 1988?
Offer a very short reply. 1.02. What is the ratio of the Pupil-teacher ratio(headcount basis) in World in 1986 to that in 1988?
Offer a terse response. 1.01. What is the ratio of the Pupil-teacher ratio(headcount basis) in Philippines in 1986 to that in 1988?
Offer a terse response. 0.95. What is the ratio of the Pupil-teacher ratio(headcount basis) in East Asia (all income levels) in 1987 to that in 1988?
Provide a succinct answer. 1.03. What is the ratio of the Pupil-teacher ratio(headcount basis) in Europe(all income levels) in 1987 to that in 1988?
Ensure brevity in your answer.  1.01. What is the ratio of the Pupil-teacher ratio(headcount basis) of World in 1987 to that in 1988?
Offer a terse response. 1.01. What is the ratio of the Pupil-teacher ratio(headcount basis) in Philippines in 1987 to that in 1988?
Make the answer very short. 0.99. What is the difference between the highest and the second highest Pupil-teacher ratio(headcount basis) in East Asia (all income levels)?
Your response must be concise. 0.11. What is the difference between the highest and the second highest Pupil-teacher ratio(headcount basis) in Europe(all income levels)?
Make the answer very short. 0.02. What is the difference between the highest and the second highest Pupil-teacher ratio(headcount basis) of World?
Offer a very short reply. 0.03. What is the difference between the highest and the second highest Pupil-teacher ratio(headcount basis) of Philippines?
Your answer should be very brief. 0.73. What is the difference between the highest and the lowest Pupil-teacher ratio(headcount basis) in East Asia (all income levels)?
Your response must be concise. 0.8. What is the difference between the highest and the lowest Pupil-teacher ratio(headcount basis) of Europe(all income levels)?
Offer a terse response. 0.25. What is the difference between the highest and the lowest Pupil-teacher ratio(headcount basis) in World?
Your answer should be compact. 0.23. What is the difference between the highest and the lowest Pupil-teacher ratio(headcount basis) of Philippines?
Offer a terse response. 2.87. 